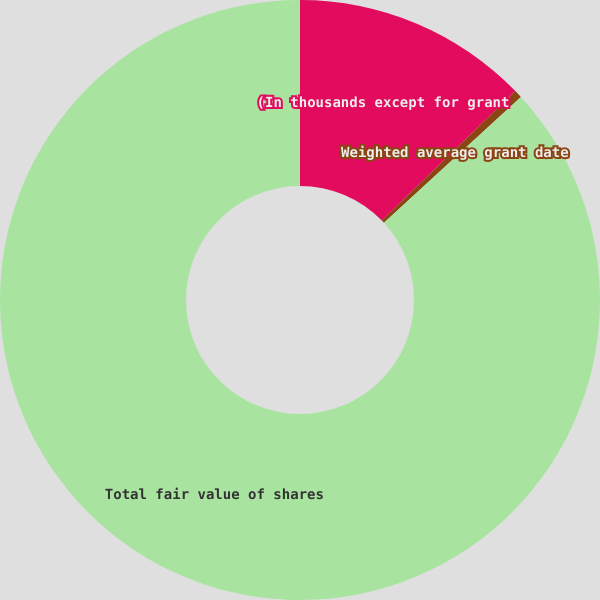Convert chart. <chart><loc_0><loc_0><loc_500><loc_500><pie_chart><fcel>(In thousands except for grant<fcel>Weighted average grant date<fcel>Total fair value of shares<nl><fcel>12.74%<fcel>0.43%<fcel>86.82%<nl></chart> 